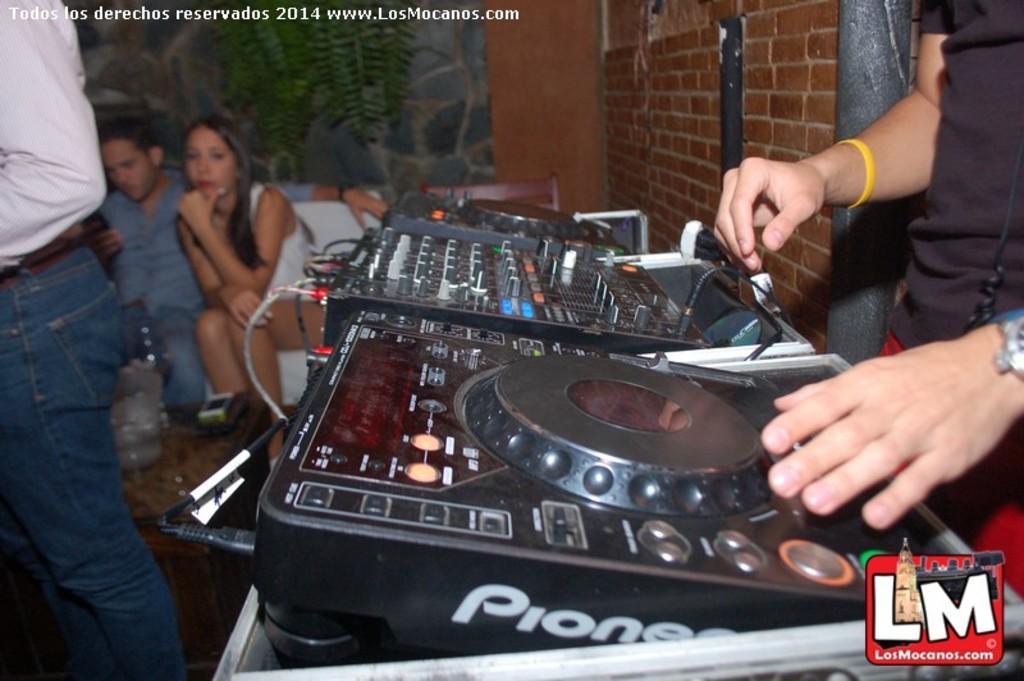Could you give a brief overview of what you see in this image? In this image we can see a person holding a musical instrument and we can also see plants, walls and people. 